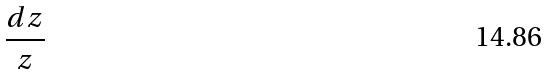Convert formula to latex. <formula><loc_0><loc_0><loc_500><loc_500>\frac { d z } { z }</formula> 